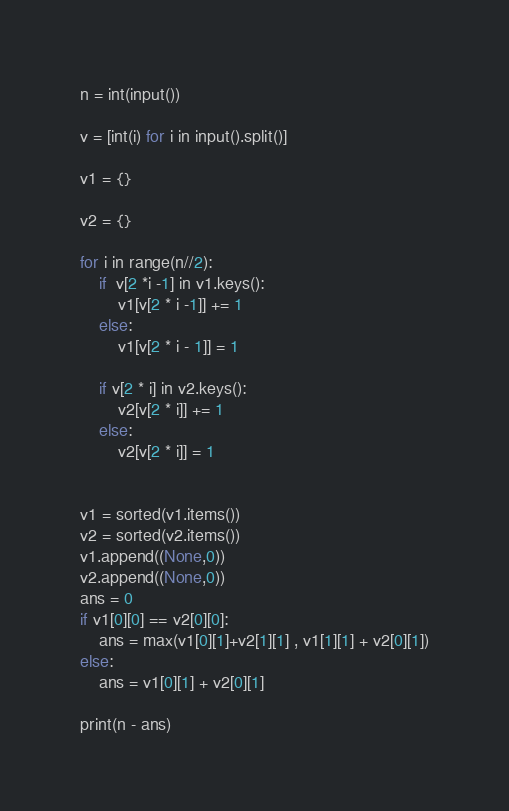Convert code to text. <code><loc_0><loc_0><loc_500><loc_500><_Python_>n = int(input())

v = [int(i) for i in input().split()]

v1 = {}

v2 = {}

for i in range(n//2):
    if  v[2 *i -1] in v1.keys():
        v1[v[2 * i -1]] += 1
    else:
        v1[v[2 * i - 1]] = 1

    if v[2 * i] in v2.keys():
        v2[v[2 * i]] += 1
    else:
        v2[v[2 * i]] = 1


v1 = sorted(v1.items())
v2 = sorted(v2.items())
v1.append((None,0))
v2.append((None,0))
ans = 0
if v1[0][0] == v2[0][0]:
    ans = max(v1[0][1]+v2[1][1] , v1[1][1] + v2[0][1])
else:
    ans = v1[0][1] + v2[0][1]

print(n - ans)</code> 